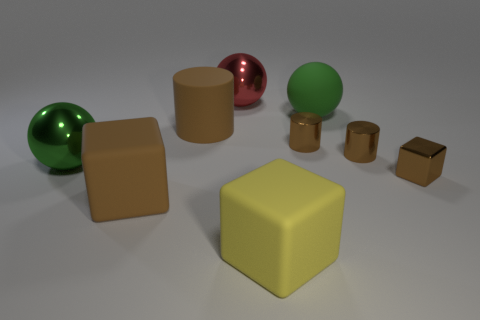Subtract all red spheres. How many spheres are left? 2 Subtract all brown matte cubes. How many cubes are left? 2 Subtract 3 spheres. How many spheres are left? 0 Subtract all green cylinders. How many brown blocks are left? 2 Subtract all green spheres. Subtract all small brown metallic objects. How many objects are left? 4 Add 7 brown shiny blocks. How many brown shiny blocks are left? 8 Add 5 small yellow metal spheres. How many small yellow metal spheres exist? 5 Subtract 1 yellow blocks. How many objects are left? 8 Subtract all brown cubes. Subtract all yellow cylinders. How many cubes are left? 1 